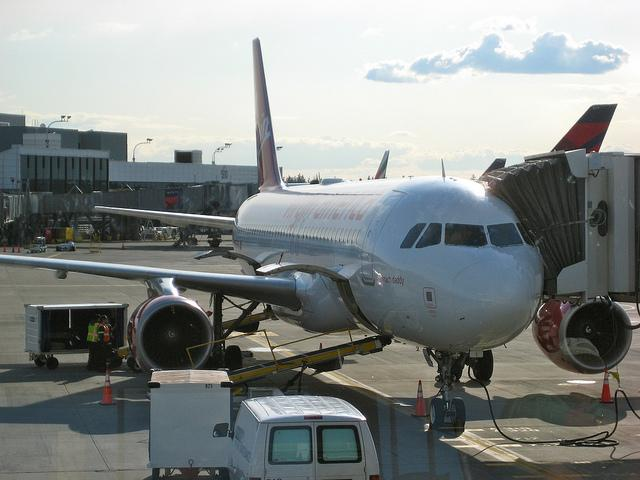Who created the first successful vehicle of this type?

Choices:
A) elon musk
B) nikola tesla
C) orville wright
D) karl benz orville wright 